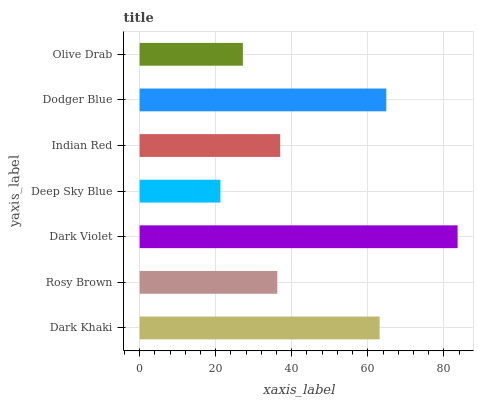Is Deep Sky Blue the minimum?
Answer yes or no. Yes. Is Dark Violet the maximum?
Answer yes or no. Yes. Is Rosy Brown the minimum?
Answer yes or no. No. Is Rosy Brown the maximum?
Answer yes or no. No. Is Dark Khaki greater than Rosy Brown?
Answer yes or no. Yes. Is Rosy Brown less than Dark Khaki?
Answer yes or no. Yes. Is Rosy Brown greater than Dark Khaki?
Answer yes or no. No. Is Dark Khaki less than Rosy Brown?
Answer yes or no. No. Is Indian Red the high median?
Answer yes or no. Yes. Is Indian Red the low median?
Answer yes or no. Yes. Is Deep Sky Blue the high median?
Answer yes or no. No. Is Rosy Brown the low median?
Answer yes or no. No. 